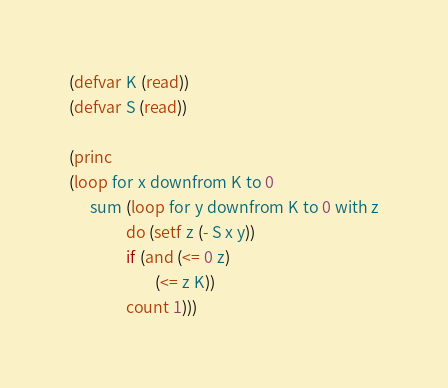Convert code to text. <code><loc_0><loc_0><loc_500><loc_500><_Lisp_>(defvar K (read))
(defvar S (read))

(princ
(loop for x downfrom K to 0
      sum (loop for y downfrom K to 0 with z
                do (setf z (- S x y))
                if (and (<= 0 z)
                        (<= z K))
                count 1)))</code> 